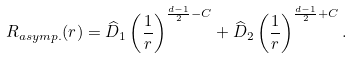<formula> <loc_0><loc_0><loc_500><loc_500>\ R _ { a s y m p . } ( r ) = \widehat { D } _ { 1 } \left ( \frac { 1 } { r } \right ) ^ { \frac { d - 1 } { 2 } - C } + \widehat { D } _ { 2 } \left ( \frac { 1 } { r } \right ) ^ { \frac { d - 1 } { 2 } + C } .</formula> 